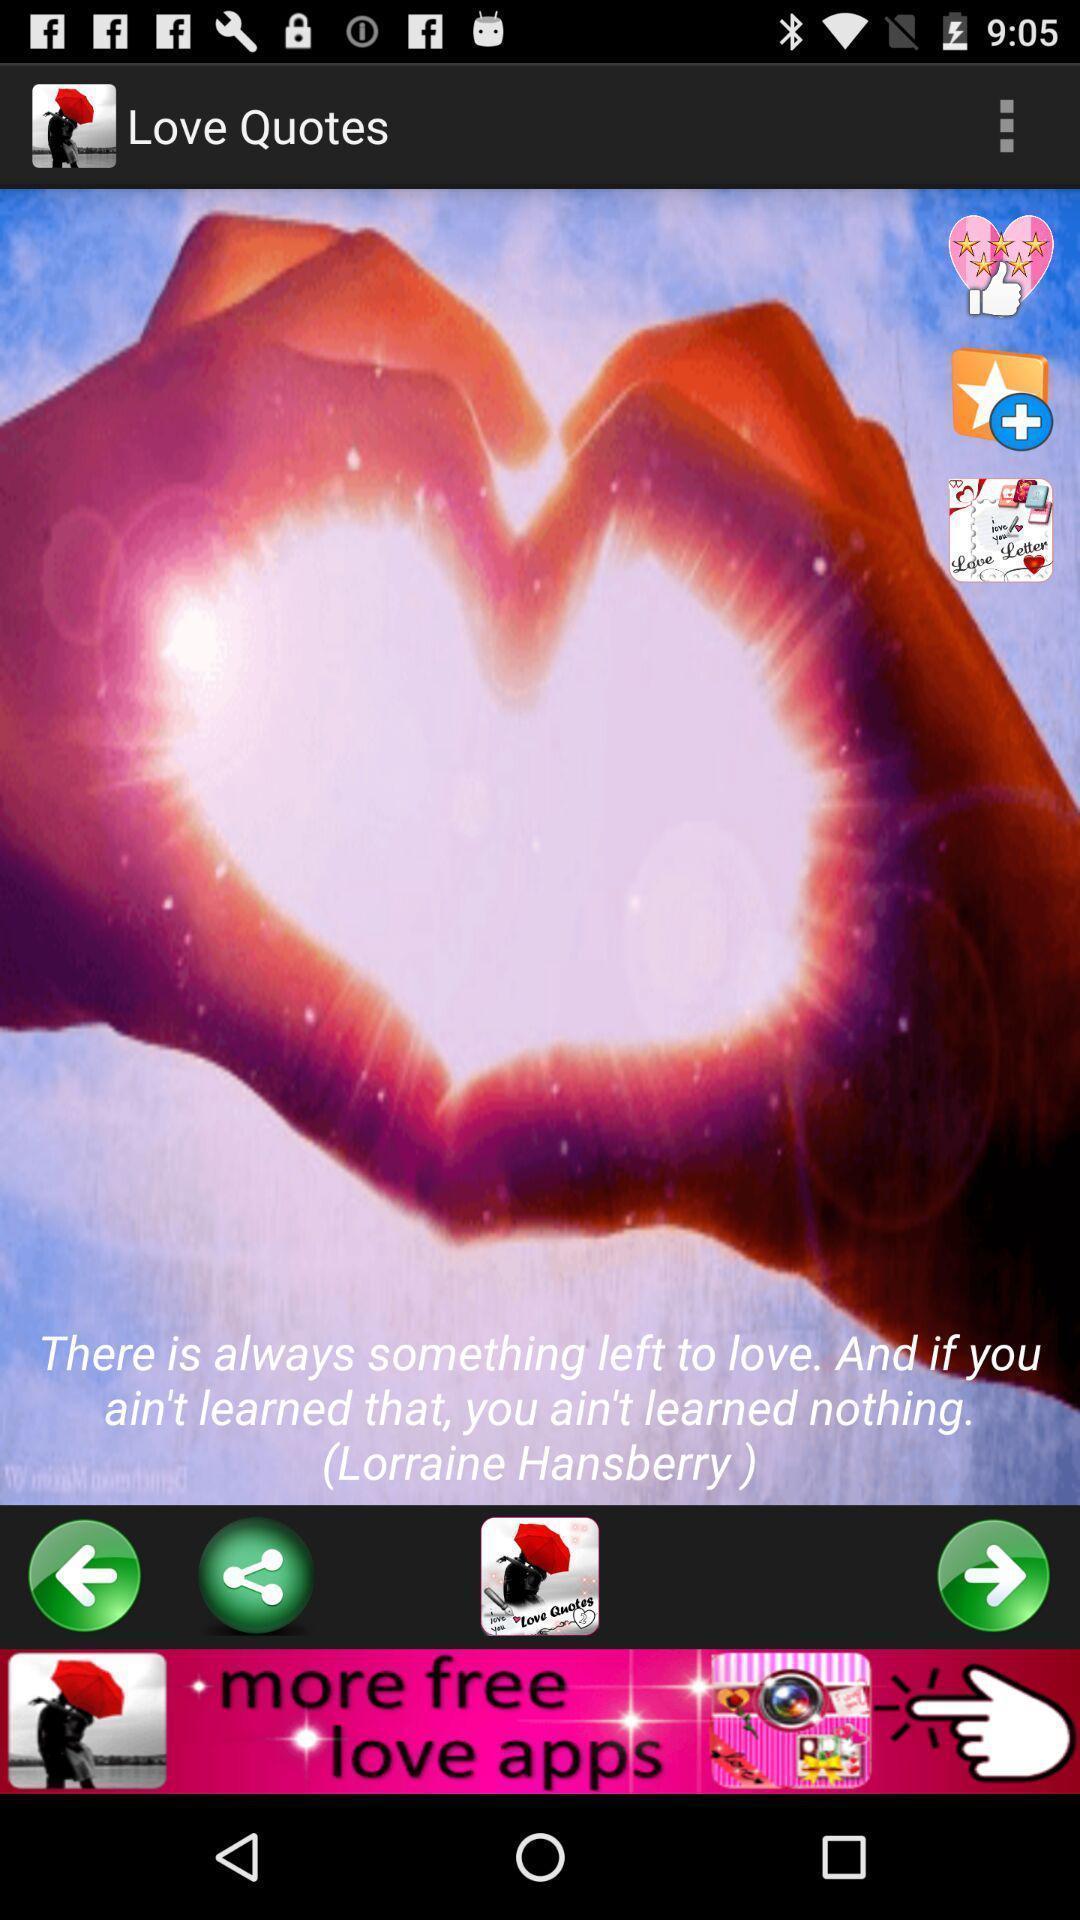Tell me what you see in this picture. Screen displaying the quote with background image. 